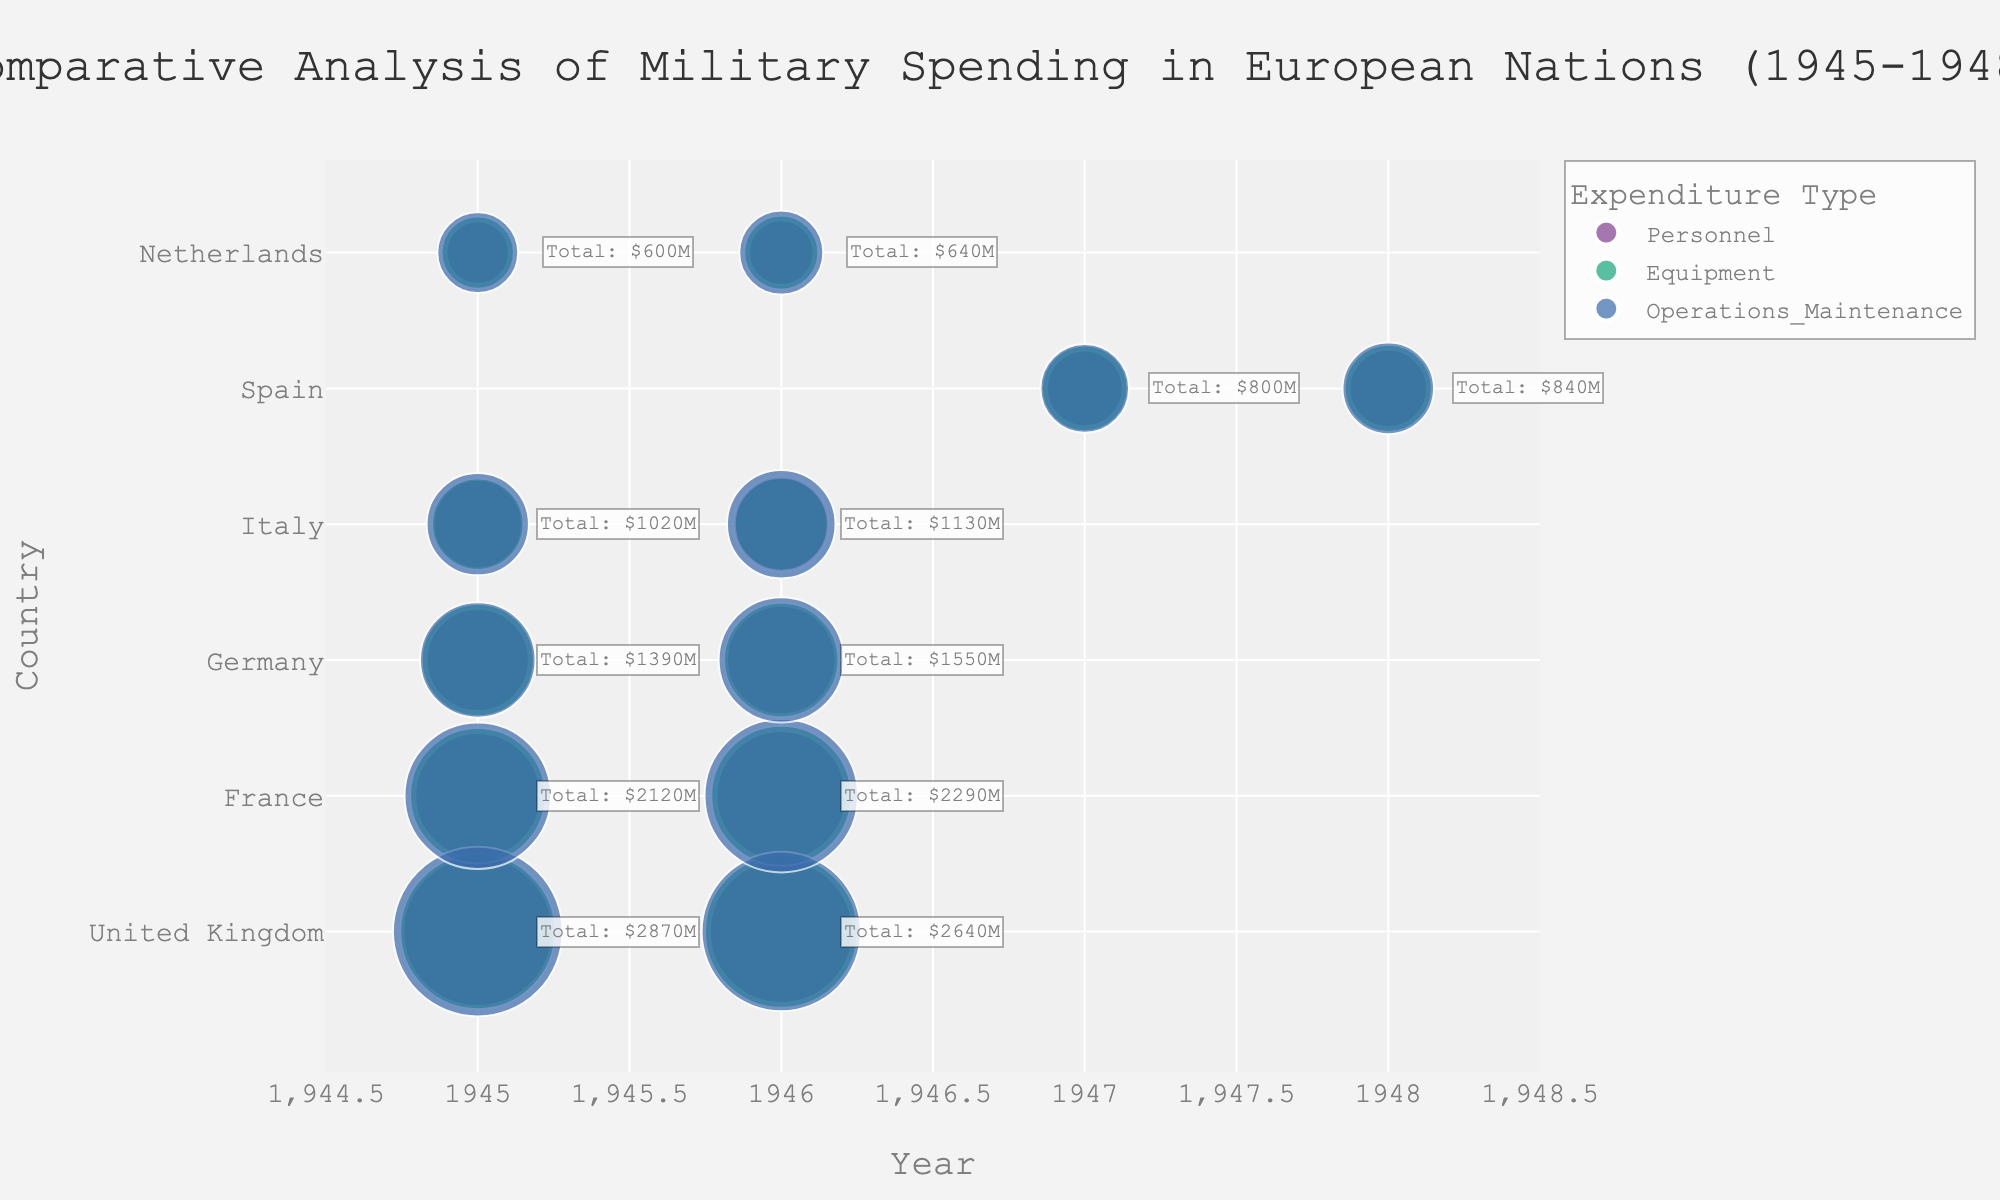What is the title of the chart? The title is located at the top of the figure and is usually in a larger font size compared to other text. It provides a summary of what the chart is about.
Answer: Comparative Analysis of Military Spending in European Nations (1945-1948) Which country has the highest total military spending in 1945? To find this, look for the annotations that show the total spending for each country in 1945. Compare these values to identify the highest one.
Answer: United Kingdom What colors are used to represent the different expenditure types? The colors represent different categories and are usually indicated in a legend. The categories are "Personnel," "Equipment," and "Operations_Maintenance."
Answer: Bold colors from the qualitative palette How does the spending on Equipment in France in 1946 compare to that in 1945? Locate the bubbles for France in the years 1945 and 1946. Compare the sizes of the bubbles related to "Equipment" expenditure type in both years.
Answer: It increased from $700M to $750M What is the total spending of Italy in 1946? Look at the annotation next to Italy for the year 1946.
Answer: $1130M Which country shows a visible increase in Operations_Maintenance spending between 1945 and 1946? Identify the bubbles for Operations_Maintenance in 1945 and 1946 for each country. Compare their sizes to see which country has visibly increased spending.
Answer: Germany Compare the Personnel spending in the United Kingdom for the years 1945 and 1946. Look for the bubbles that represent "Personnel" expenditure in the United Kingdom for both years and check their sizes.
Answer: It decreased from $850M to $780M What does a larger bubble represent in this bubble chart? In a bubble chart, the size of the bubble is proportional to the value it represents. Larger bubbles indicate higher values.
Answer: Higher military spending in USD millions Which country has the smallest total spending in 1945? Check the annotations for total spending next to each country in 1945 and identify the smallest one.
Answer: Netherlands Between France and Italy, which country spent more on Equipment in 1945? Look for the bubbles representing "Equipment" in France and Italy in the year 1945 and compare their sizes.
Answer: France 